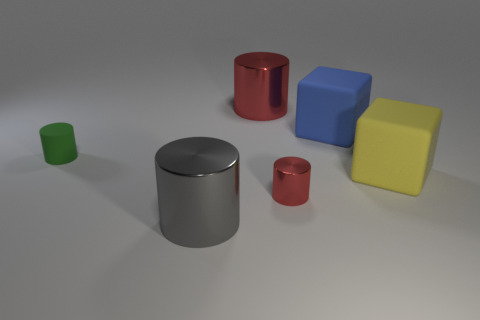Add 1 yellow rubber cubes. How many objects exist? 7 Subtract all small red shiny cylinders. How many cylinders are left? 3 Subtract all green cylinders. How many cylinders are left? 3 Subtract 1 cylinders. How many cylinders are left? 3 Add 1 cylinders. How many cylinders exist? 5 Subtract 2 red cylinders. How many objects are left? 4 Subtract all cylinders. How many objects are left? 2 Subtract all blue blocks. Subtract all yellow balls. How many blocks are left? 1 Subtract all blue spheres. How many blue cubes are left? 1 Subtract all large gray cylinders. Subtract all small red things. How many objects are left? 4 